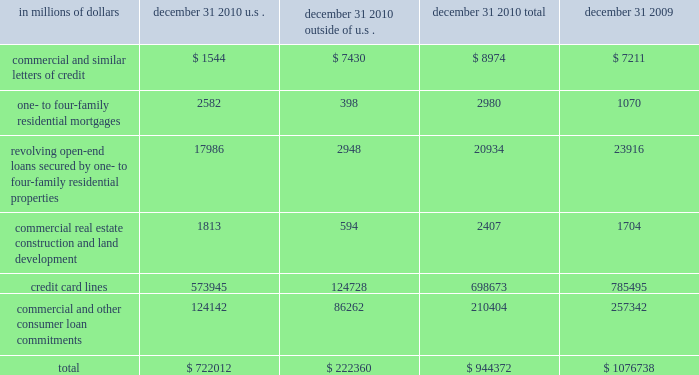Credit commitments and lines of credit the table below summarizes citigroup 2019s credit commitments as of december 31 , 2010 and december 31 , 2009: .
The majority of unused commitments are contingent upon customers maintaining specific credit standards .
Commercial commitments generally have floating interest rates and fixed expiration dates and may require payment of fees .
Such fees ( net of certain direct costs ) are deferred and , upon exercise of the commitment , amortized over the life of the loan or , if exercise is deemed remote , amortized over the commitment period .
Commercial and similar letters of credit a commercial letter of credit is an instrument by which citigroup substitutes its credit for that of a customer to enable the customer to finance the purchase of goods or to incur other commitments .
Citigroup issues a letter on behalf of its client to a supplier and agrees to pay the supplier upon presentation of documentary evidence that the supplier has performed in accordance with the terms of the letter of credit .
When a letter of credit is drawn , the customer is then required to reimburse citigroup .
One- to four-family residential mortgages a one- to four-family residential mortgage commitment is a written confirmation from citigroup to a seller of a property that the bank will advance the specified sums enabling the buyer to complete the purchase .
Revolving open-end loans secured by one- to four-family residential properties revolving open-end loans secured by one- to four-family residential properties are essentially home equity lines of credit .
A home equity line of credit is a loan secured by a primary residence or second home to the extent of the excess of fair market value over the debt outstanding for the first mortgage .
Commercial real estate , construction and land development commercial real estate , construction and land development include unused portions of commitments to extend credit for the purpose of financing commercial and multifamily residential properties as well as land development projects .
Both secured-by-real-estate and unsecured commitments are included in this line , as well as undistributed loan proceeds , where there is an obligation to advance for construction progress payments .
However , this line only includes those extensions of credit that , once funded , will be classified as loans on the consolidated balance sheet .
Credit card lines citigroup provides credit to customers by issuing credit cards .
The credit card lines are unconditionally cancelable by the issuer .
Commercial and other consumer loan commitments commercial and other consumer loan commitments include overdraft and liquidity facilities , as well as commercial commitments to make or purchase loans , to purchase third-party receivables , to provide note issuance or revolving underwriting facilities and to invest in the form of equity .
Amounts include $ 79 billion and $ 126 billion with an original maturity of less than one year at december 31 , 2010 and december 31 , 2009 , respectively .
In addition , included in this line item are highly leveraged financing commitments , which are agreements that provide funding to a borrower with higher levels of debt ( measured by the ratio of debt capital to equity capital of the borrower ) than is generally considered normal for other companies .
This type of financing is commonly employed in corporate acquisitions , management buy-outs and similar transactions. .
What percentage of citigroup 2019s credit commitments as of december 31 , 2010 are u.s.? 
Computations: (722012 / 944372)
Answer: 0.76454. 